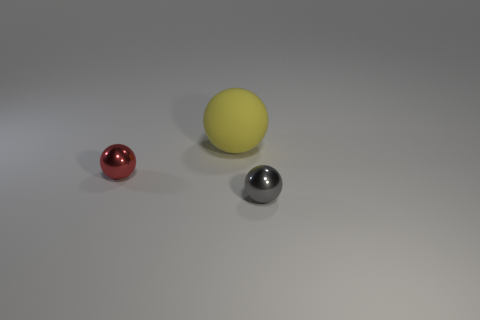Is the light source in the image coming from a specific direction? Yes, the shadows cast by the spheres suggest that the light source is coming from the upper left direction relative to the image's perspective. 